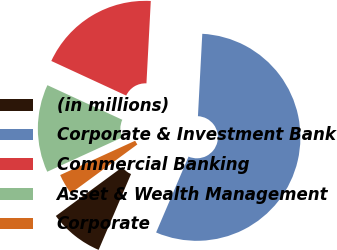Convert chart. <chart><loc_0><loc_0><loc_500><loc_500><pie_chart><fcel>(in millions)<fcel>Corporate & Investment Bank<fcel>Commercial Banking<fcel>Asset & Wealth Management<fcel>Corporate<nl><fcel>8.49%<fcel>55.59%<fcel>18.95%<fcel>13.72%<fcel>3.25%<nl></chart> 